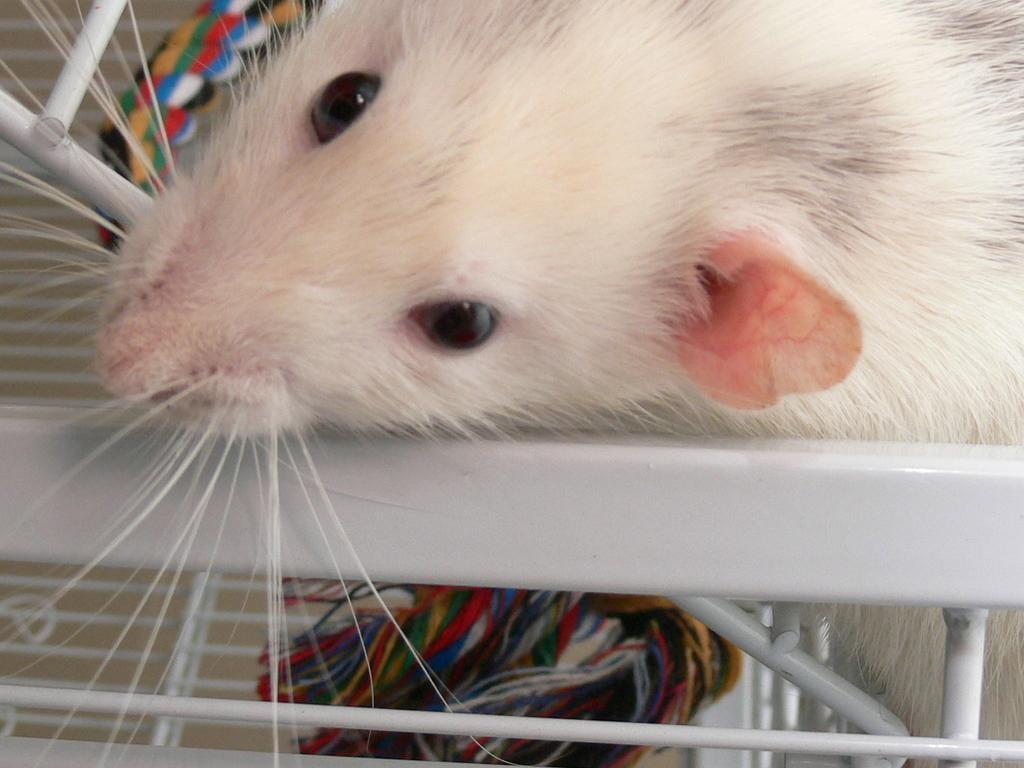Could you give a brief overview of what you see in this image? In this image, this looks like a rat, which is white in color. I think I can see the colorful threads. This looks like a metal object. 